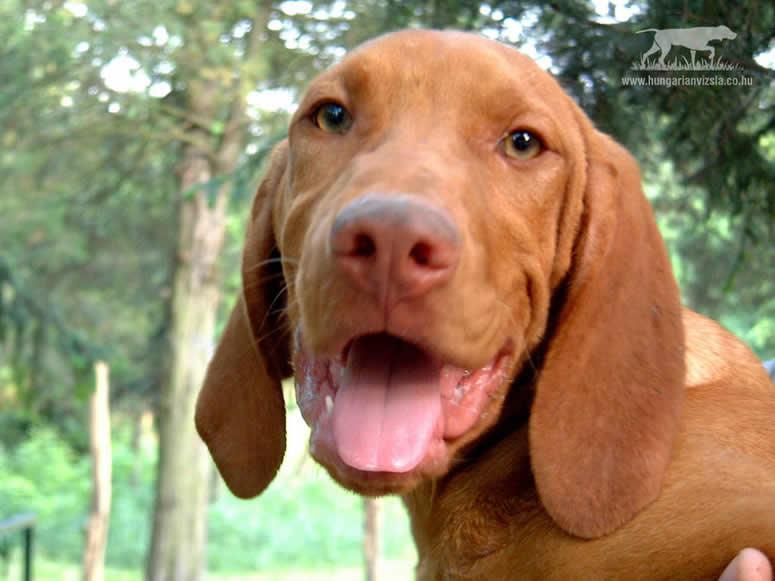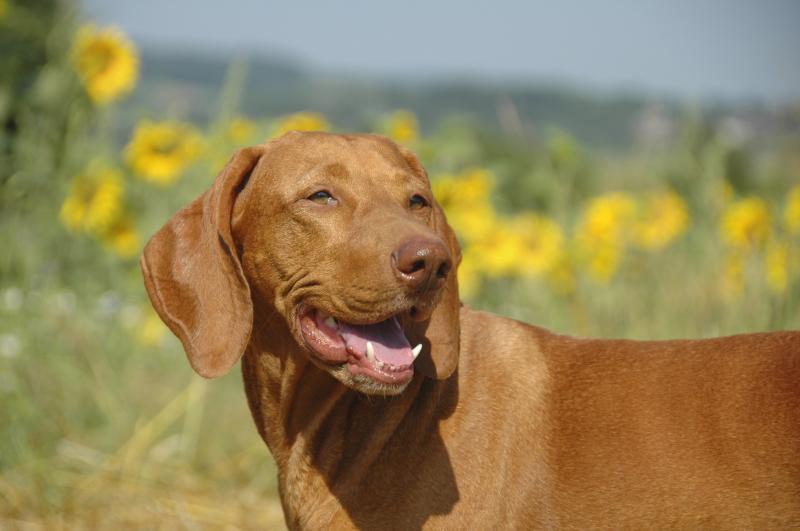The first image is the image on the left, the second image is the image on the right. Examine the images to the left and right. Is the description "At least one dog has its mouth open." accurate? Answer yes or no. Yes. The first image is the image on the left, the second image is the image on the right. Examine the images to the left and right. Is the description "The lefthand dog has long floppy ears and is turned slightly leftward, and the righthand dog has its head turned slightly rightward." accurate? Answer yes or no. Yes. 